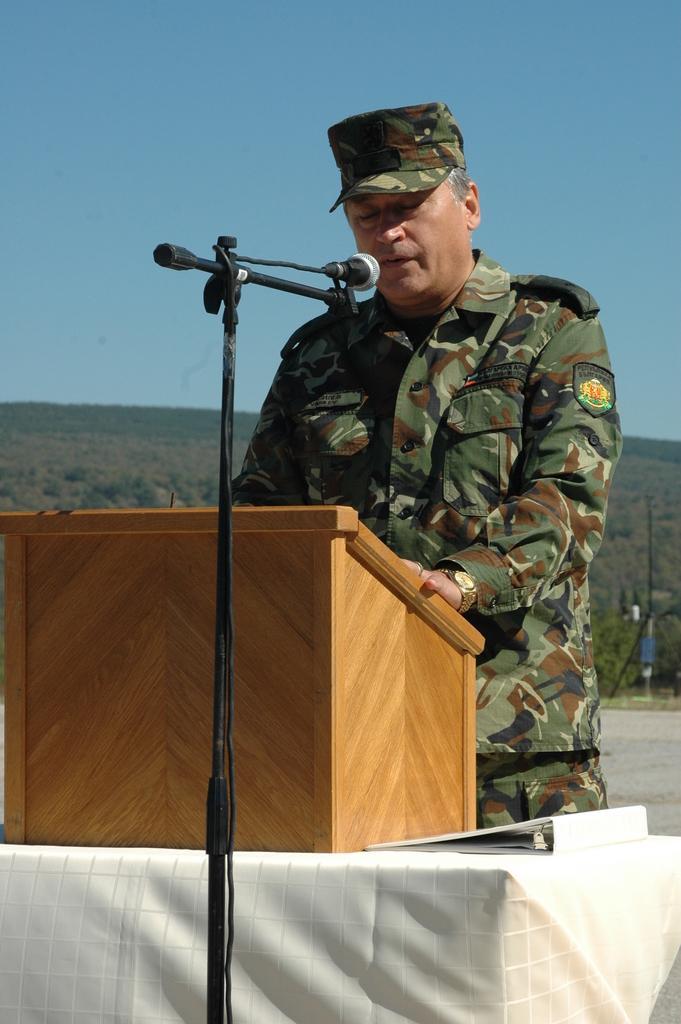In one or two sentences, can you explain what this image depicts? In this picture we can see a person, in front of him we can see a podium, mic, here we can see a table, file, at the back of him we can see a pole, ground, trees and some objects and we can see sky in the background. 